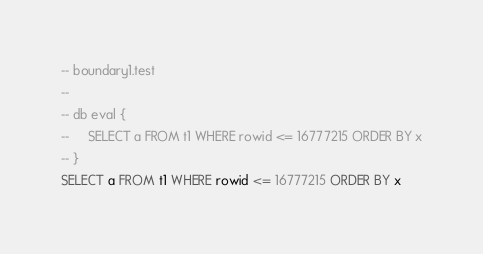Convert code to text. <code><loc_0><loc_0><loc_500><loc_500><_SQL_>-- boundary1.test
-- 
-- db eval {
--     SELECT a FROM t1 WHERE rowid <= 16777215 ORDER BY x
-- }
SELECT a FROM t1 WHERE rowid <= 16777215 ORDER BY x</code> 